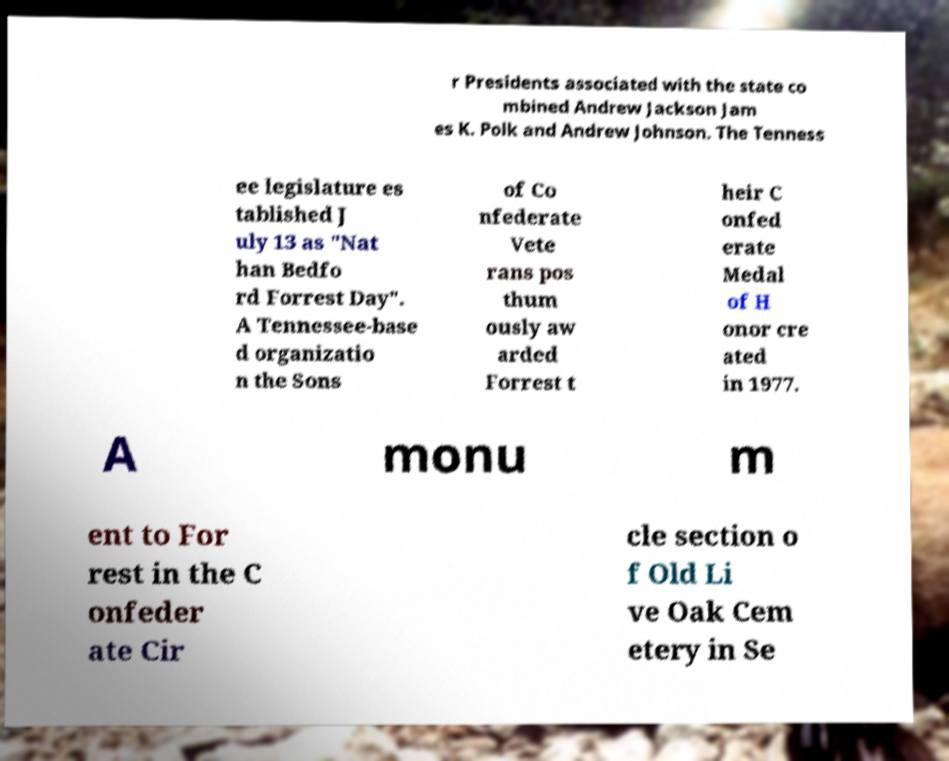What messages or text are displayed in this image? I need them in a readable, typed format. r Presidents associated with the state co mbined Andrew Jackson Jam es K. Polk and Andrew Johnson. The Tenness ee legislature es tablished J uly 13 as "Nat han Bedfo rd Forrest Day". A Tennessee-base d organizatio n the Sons of Co nfederate Vete rans pos thum ously aw arded Forrest t heir C onfed erate Medal of H onor cre ated in 1977. A monu m ent to For rest in the C onfeder ate Cir cle section o f Old Li ve Oak Cem etery in Se 